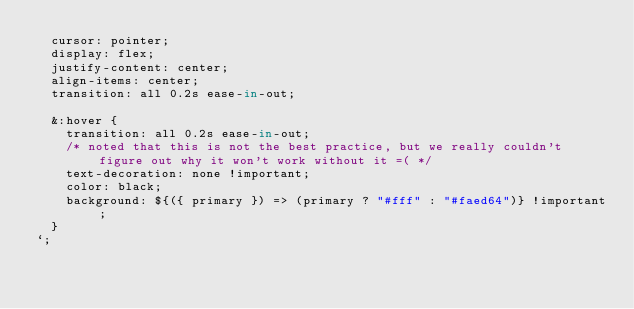<code> <loc_0><loc_0><loc_500><loc_500><_JavaScript_>  cursor: pointer;
  display: flex;
  justify-content: center;
  align-items: center;
  transition: all 0.2s ease-in-out;

  &:hover {
    transition: all 0.2s ease-in-out;
    /* noted that this is not the best practice, but we really couldn't figure out why it won't work without it =( */
    text-decoration: none !important;
    color: black;
    background: ${({ primary }) => (primary ? "#fff" : "#faed64")} !important;
  }
`;
</code> 